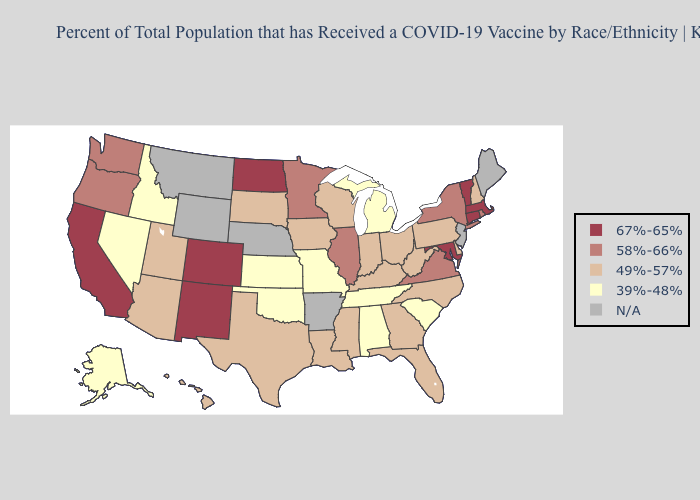What is the value of California?
Concise answer only. 67%-65%. Name the states that have a value in the range 58%-66%?
Be succinct. Illinois, Minnesota, New York, Oregon, Rhode Island, Virginia, Washington. Does Pennsylvania have the highest value in the Northeast?
Quick response, please. No. What is the value of Oregon?
Short answer required. 58%-66%. What is the value of New York?
Give a very brief answer. 58%-66%. Does Arizona have the highest value in the USA?
Concise answer only. No. Name the states that have a value in the range 58%-66%?
Short answer required. Illinois, Minnesota, New York, Oregon, Rhode Island, Virginia, Washington. Name the states that have a value in the range 67%-65%?
Write a very short answer. California, Colorado, Connecticut, Maryland, Massachusetts, New Mexico, North Dakota, Vermont. Name the states that have a value in the range 58%-66%?
Be succinct. Illinois, Minnesota, New York, Oregon, Rhode Island, Virginia, Washington. Which states have the lowest value in the USA?
Short answer required. Alabama, Alaska, Idaho, Kansas, Michigan, Missouri, Nevada, Oklahoma, South Carolina, Tennessee. Which states have the lowest value in the USA?
Write a very short answer. Alabama, Alaska, Idaho, Kansas, Michigan, Missouri, Nevada, Oklahoma, South Carolina, Tennessee. What is the value of Illinois?
Give a very brief answer. 58%-66%. Among the states that border Vermont , does New Hampshire have the lowest value?
Keep it brief. Yes. What is the lowest value in the Northeast?
Answer briefly. 49%-57%. 